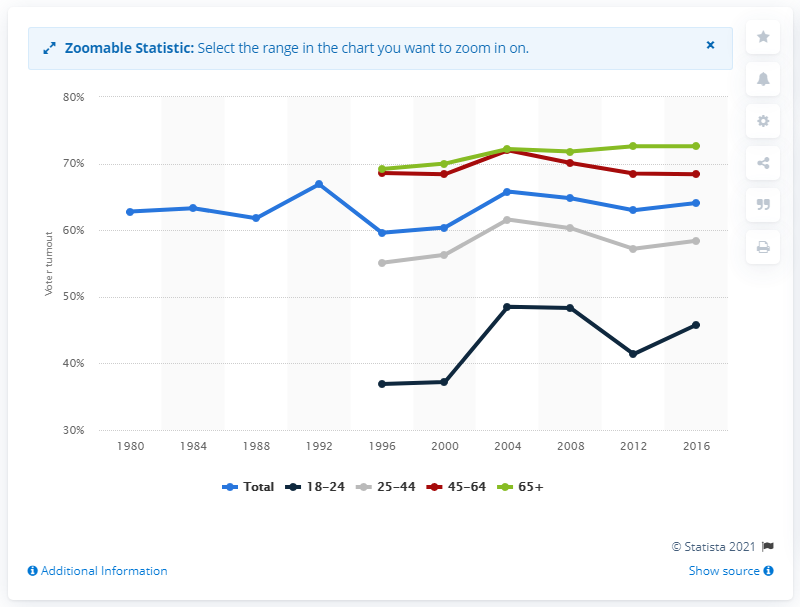Outline some significant characteristics in this image. The turnout rate for the youngest age bracket of non-Hispanic white voters was 37.2%. 